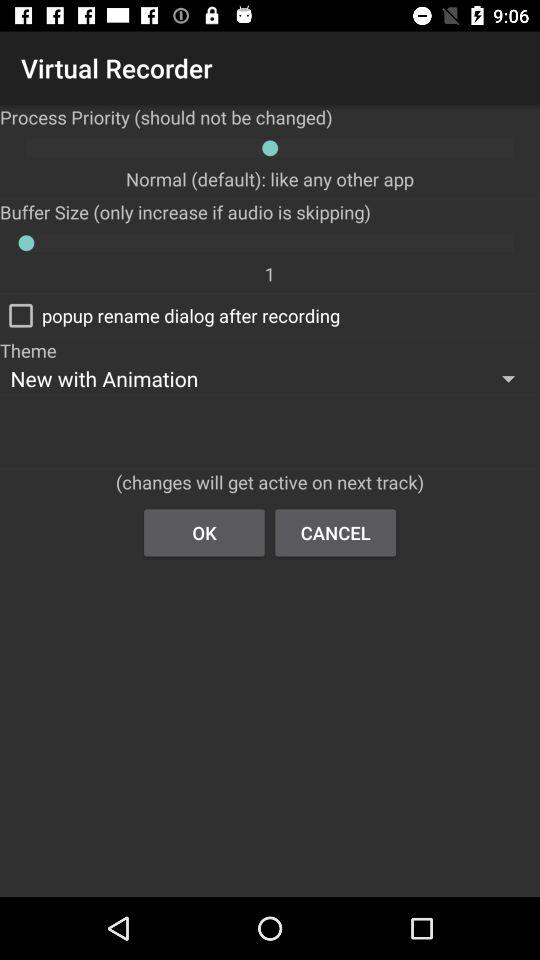What is the buffer size? The buffer size is 1. 